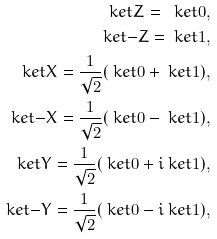<formula> <loc_0><loc_0><loc_500><loc_500>\ k e t { Z } = \ k e t { 0 } , \\ \ k e t { - Z } = \ k e t { 1 } , \\ \ k e t { X } = \frac { 1 } { \sqrt { 2 } } ( \ k e t { 0 } + \ k e t { 1 } ) , \\ \ k e t { - X } = \frac { 1 } { \sqrt { 2 } } ( \ k e t { 0 } - \ k e t { 1 } ) , \\ \ k e t { Y } = \frac { 1 } { \sqrt { 2 } } ( \ k e t { 0 } + i \ k e t { 1 } ) , \\ \ k e t { - Y } = \frac { 1 } { \sqrt { 2 } } ( \ k e t { 0 } - i \ k e t { 1 } ) ,</formula> 